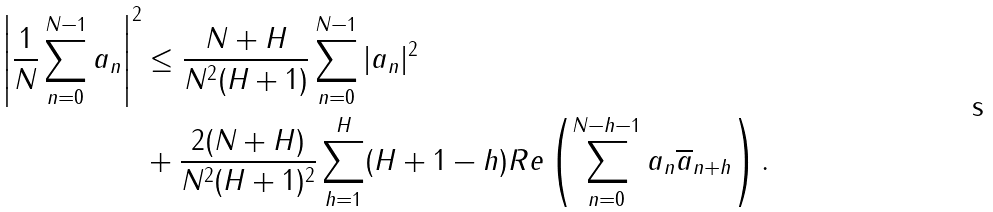<formula> <loc_0><loc_0><loc_500><loc_500>\left | \frac { 1 } { N } \sum _ { n = 0 } ^ { N - 1 } a _ { n } \right | ^ { 2 } & \leq \frac { N + H } { N ^ { 2 } ( H + 1 ) } \sum _ { n = 0 } ^ { N - 1 } | a _ { n } | ^ { 2 } \\ & + \frac { 2 ( N + H ) } { N ^ { 2 } ( H + 1 ) ^ { 2 } } \sum _ { h = 1 } ^ { H } ( H + 1 - h ) R e \left ( \sum _ { n = 0 } ^ { N - h - 1 } a _ { n } \overline { a } _ { n + h } \right ) .</formula> 